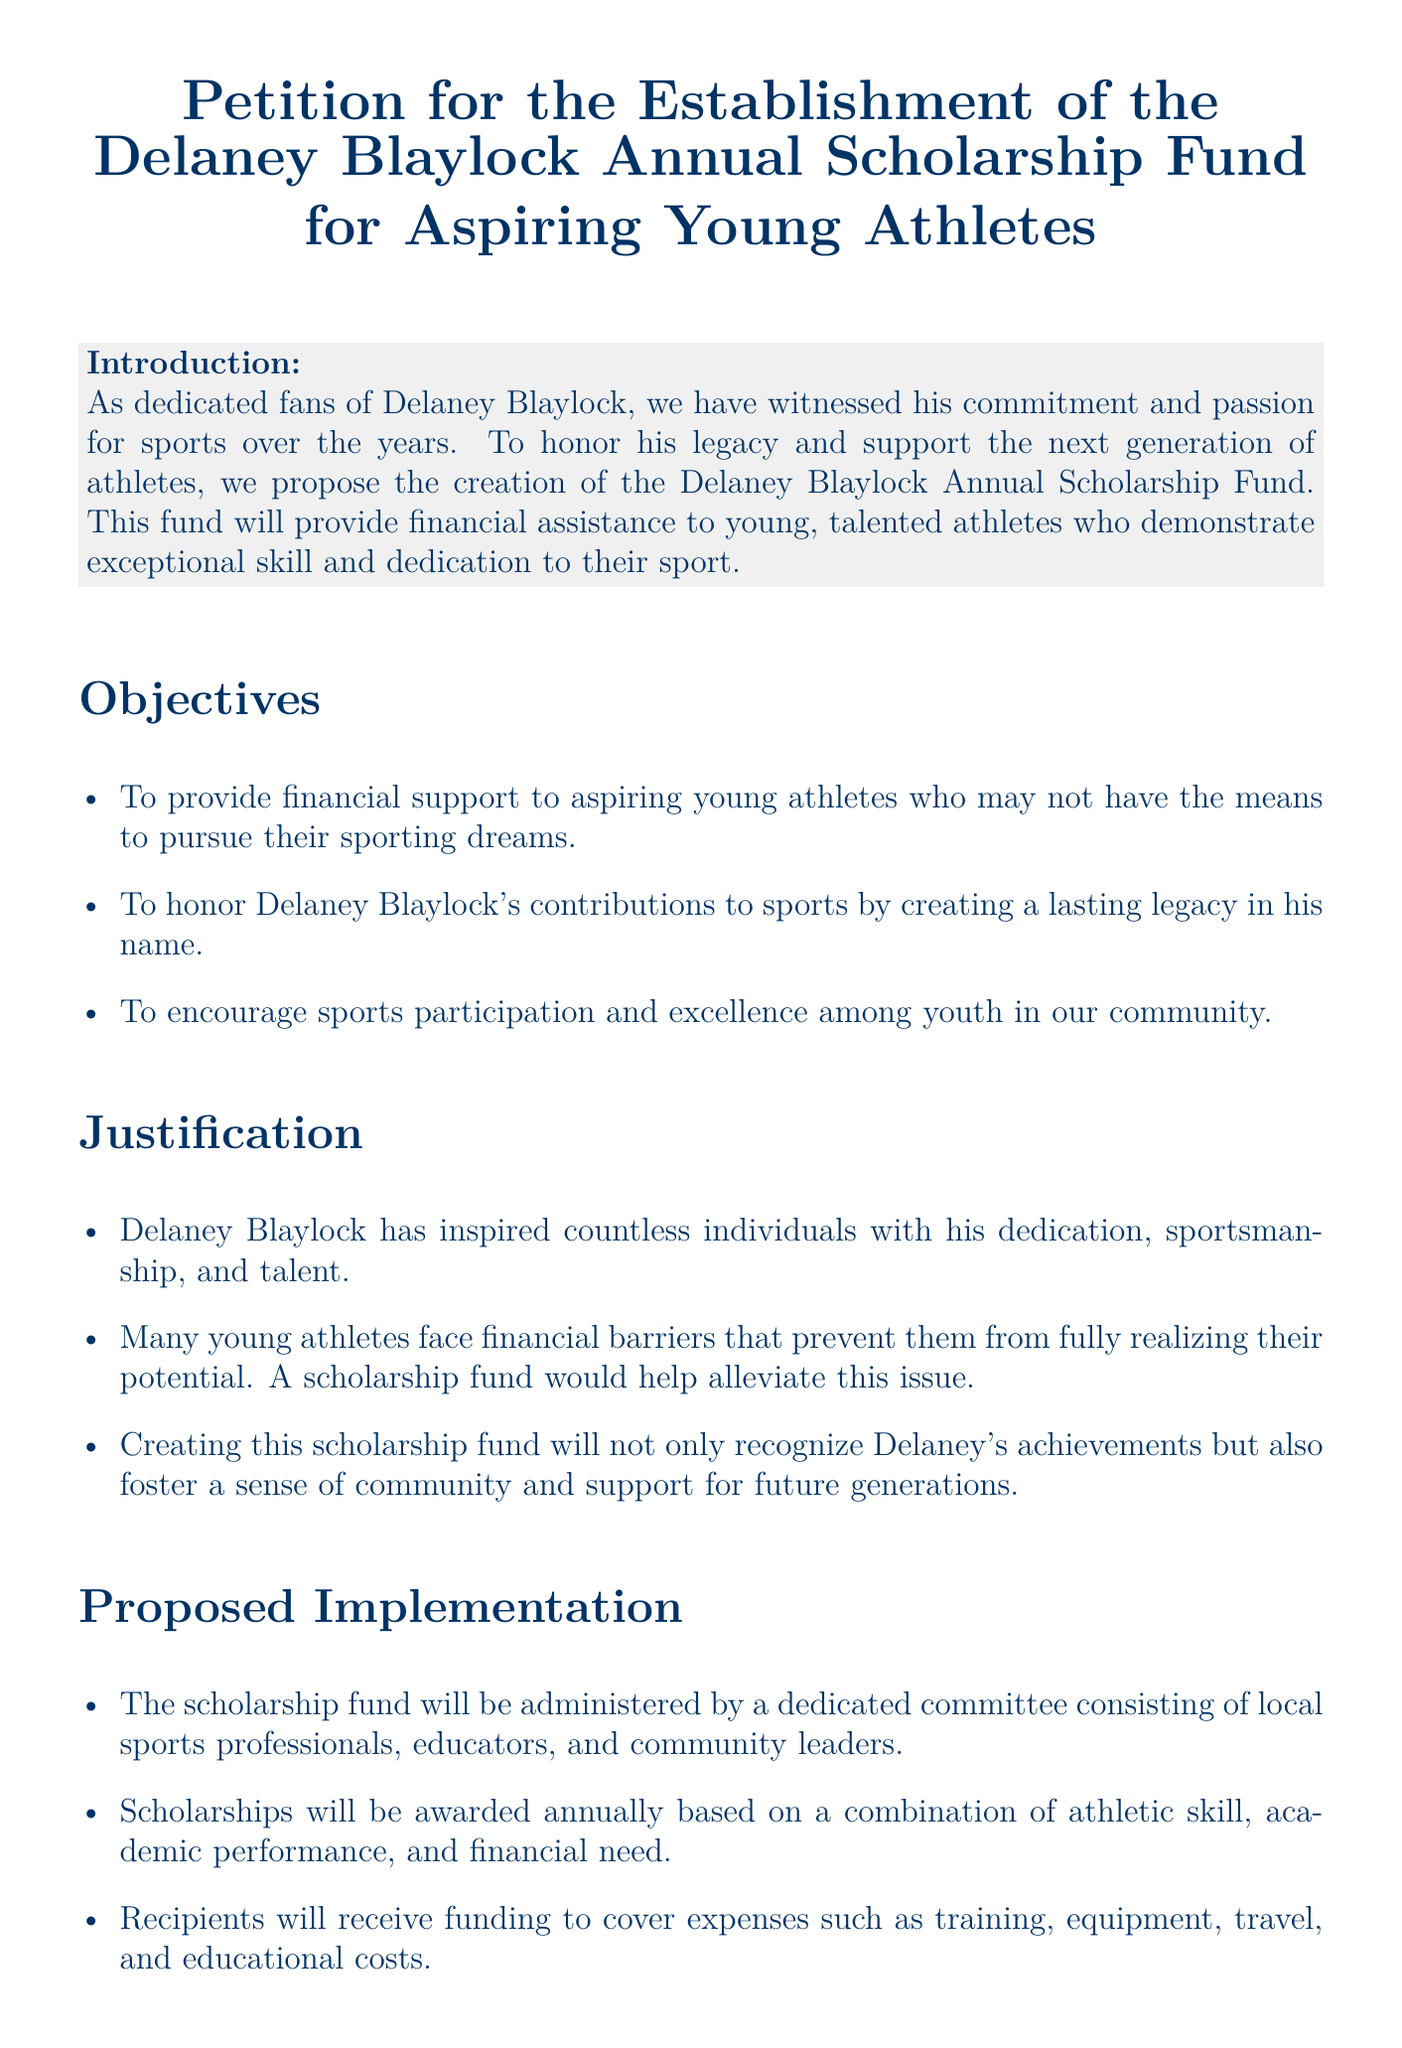What is the title of the petition? The title is clearly stated at the beginning of the document and is "Petition for the Establishment of the Delaney Blaylock Annual Scholarship Fund for Aspiring Young Athletes."
Answer: Petition for the Establishment of the Delaney Blaylock Annual Scholarship Fund for Aspiring Young Athletes Who is the scholarship fund named after? The document mentions that the scholarship fund is proposed in honor of a specific individual, Delaney Blaylock.
Answer: Delaney Blaylock What is one objective of the scholarship fund? The document lists specific objectives, one of which is to provide financial support to aspiring young athletes who may not have the means to pursue their sporting dreams.
Answer: Provide financial support to aspiring young athletes What type of individuals will administer the scholarship fund? The proposed implementation section specifies that the scholarship fund will be administered by a committee consisting of local sports professionals, educators, and community leaders.
Answer: Local sports professionals, educators, and community leaders What is included in the funding for scholarship recipients? The document outlines various expenses that the funding will cover, which includes training, equipment, travel, and educational costs.
Answer: Training, equipment, travel, and educational costs How can individuals show their support for the scholarship fund? The call to action section encourages individuals to show their support by signing the petition.
Answer: By signing the petition What is one justification for creating the scholarship fund? The document provides several justifications, one of which is that many young athletes face financial barriers preventing them from realizing their potential.
Answer: Financial barriers for young athletes How often will scholarships be awarded? The proposed implementation details that scholarships will be awarded annually.
Answer: Annually 